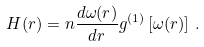Convert formula to latex. <formula><loc_0><loc_0><loc_500><loc_500>H ( r ) = n \frac { d \omega ( r ) } { d r } g ^ { ( 1 ) } \left [ \omega ( r ) \right ] \, .</formula> 